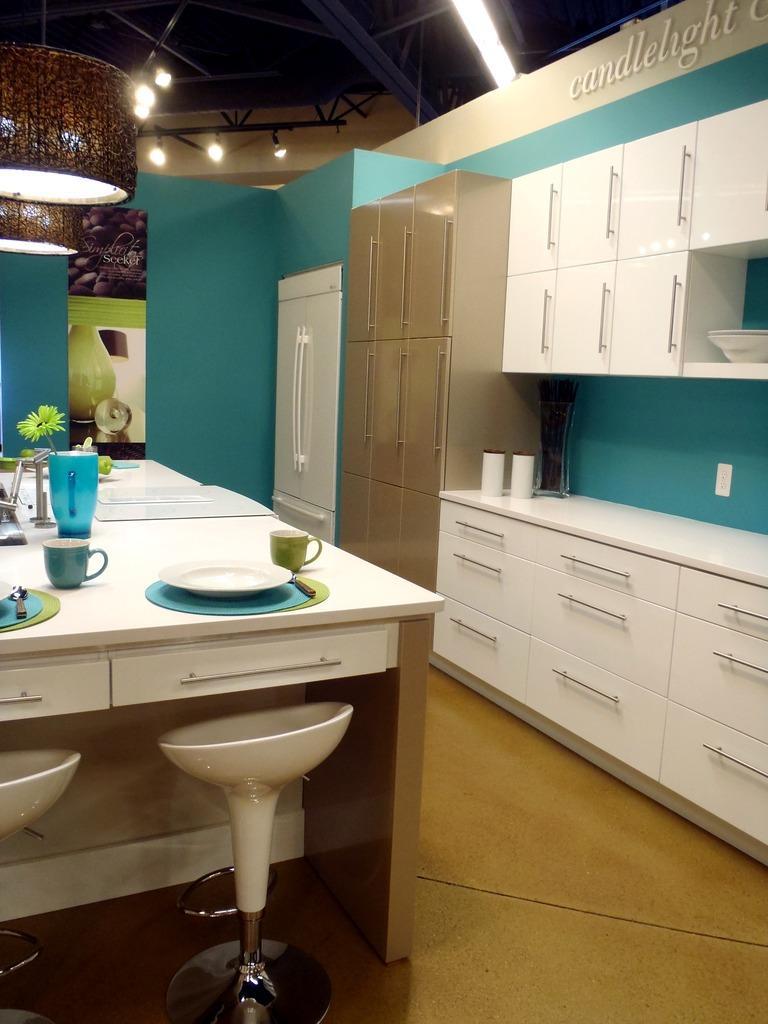Could you give a brief overview of what you see in this image? In this image on the left side there is a table, on the table there are plates, cups, jug and some flowers. Beside the table there are chairs, and on the right side there is a cupboard fridge. On the cupboard there are some objects and in the background there is wall. At the top there are some lights and ceiling. 